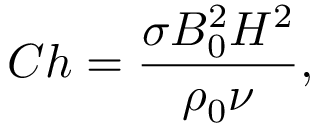Convert formula to latex. <formula><loc_0><loc_0><loc_500><loc_500>C h = \frac { \sigma B _ { 0 } ^ { 2 } H ^ { 2 } } { \rho _ { 0 } \nu } ,</formula> 